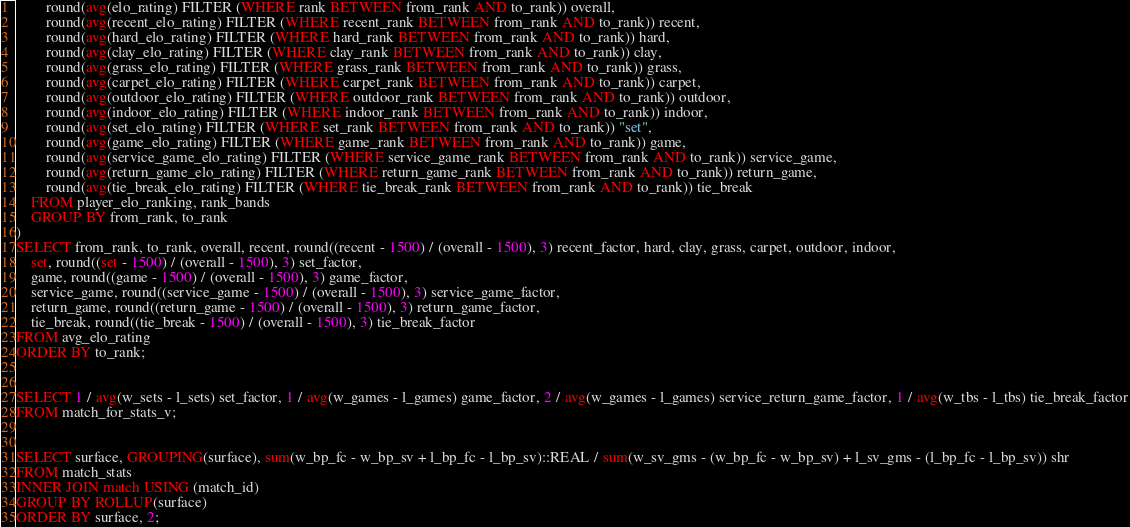<code> <loc_0><loc_0><loc_500><loc_500><_SQL_>		round(avg(elo_rating) FILTER (WHERE rank BETWEEN from_rank AND to_rank)) overall,
		round(avg(recent_elo_rating) FILTER (WHERE recent_rank BETWEEN from_rank AND to_rank)) recent,
		round(avg(hard_elo_rating) FILTER (WHERE hard_rank BETWEEN from_rank AND to_rank)) hard,
		round(avg(clay_elo_rating) FILTER (WHERE clay_rank BETWEEN from_rank AND to_rank)) clay,
		round(avg(grass_elo_rating) FILTER (WHERE grass_rank BETWEEN from_rank AND to_rank)) grass,
		round(avg(carpet_elo_rating) FILTER (WHERE carpet_rank BETWEEN from_rank AND to_rank)) carpet,
		round(avg(outdoor_elo_rating) FILTER (WHERE outdoor_rank BETWEEN from_rank AND to_rank)) outdoor,
		round(avg(indoor_elo_rating) FILTER (WHERE indoor_rank BETWEEN from_rank AND to_rank)) indoor,
		round(avg(set_elo_rating) FILTER (WHERE set_rank BETWEEN from_rank AND to_rank)) "set",
		round(avg(game_elo_rating) FILTER (WHERE game_rank BETWEEN from_rank AND to_rank)) game,
		round(avg(service_game_elo_rating) FILTER (WHERE service_game_rank BETWEEN from_rank AND to_rank)) service_game,
		round(avg(return_game_elo_rating) FILTER (WHERE return_game_rank BETWEEN from_rank AND to_rank)) return_game,
		round(avg(tie_break_elo_rating) FILTER (WHERE tie_break_rank BETWEEN from_rank AND to_rank)) tie_break
	FROM player_elo_ranking, rank_bands
	GROUP BY from_rank, to_rank
)
SELECT from_rank, to_rank, overall, recent, round((recent - 1500) / (overall - 1500), 3) recent_factor, hard, clay, grass, carpet, outdoor, indoor,
	set, round((set - 1500) / (overall - 1500), 3) set_factor,
	game, round((game - 1500) / (overall - 1500), 3) game_factor,
	service_game, round((service_game - 1500) / (overall - 1500), 3) service_game_factor,
	return_game, round((return_game - 1500) / (overall - 1500), 3) return_game_factor,
	tie_break, round((tie_break - 1500) / (overall - 1500), 3) tie_break_factor
FROM avg_elo_rating
ORDER BY to_rank;


SELECT 1 / avg(w_sets - l_sets) set_factor, 1 / avg(w_games - l_games) game_factor, 2 / avg(w_games - l_games) service_return_game_factor, 1 / avg(w_tbs - l_tbs) tie_break_factor
FROM match_for_stats_v;


SELECT surface, GROUPING(surface), sum(w_bp_fc - w_bp_sv + l_bp_fc - l_bp_sv)::REAL / sum(w_sv_gms - (w_bp_fc - w_bp_sv) + l_sv_gms - (l_bp_fc - l_bp_sv)) shr
FROM match_stats
INNER JOIN match USING (match_id)
GROUP BY ROLLUP(surface)
ORDER BY surface, 2;</code> 